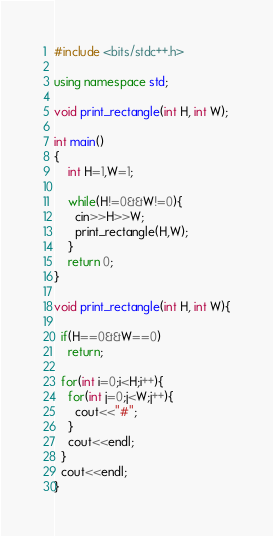<code> <loc_0><loc_0><loc_500><loc_500><_C++_>#include <bits/stdc++.h> 
 
using namespace std; 
 
void print_rectangle(int H, int W);

int main() 
{
	int H=1,W=1;
  
    while(H!=0&&W!=0){
      cin>>H>>W;
      print_rectangle(H,W);
    }
    return 0;
}

void print_rectangle(int H, int W){
  
  if(H==0&&W==0)
    return;
  
  for(int i=0;i<H;i++){
    for(int j=0;j<W;j++){
      cout<<"#";
    }
    cout<<endl;
  } 
  cout<<endl;
}


</code> 